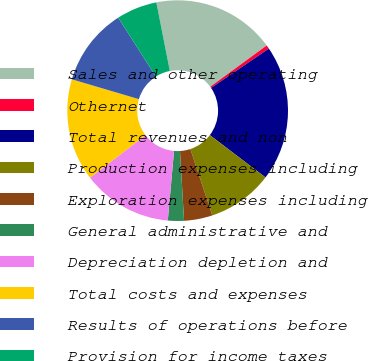Convert chart. <chart><loc_0><loc_0><loc_500><loc_500><pie_chart><fcel>Sales and other operating<fcel>Othernet<fcel>Total revenues and non<fcel>Production expenses including<fcel>Exploration expenses including<fcel>General administrative and<fcel>Depreciation depletion and<fcel>Total costs and expenses<fcel>Results of operations before<fcel>Provision for income taxes<nl><fcel>18.04%<fcel>0.55%<fcel>19.85%<fcel>9.57%<fcel>4.16%<fcel>2.35%<fcel>13.18%<fcel>14.98%<fcel>11.37%<fcel>5.96%<nl></chart> 